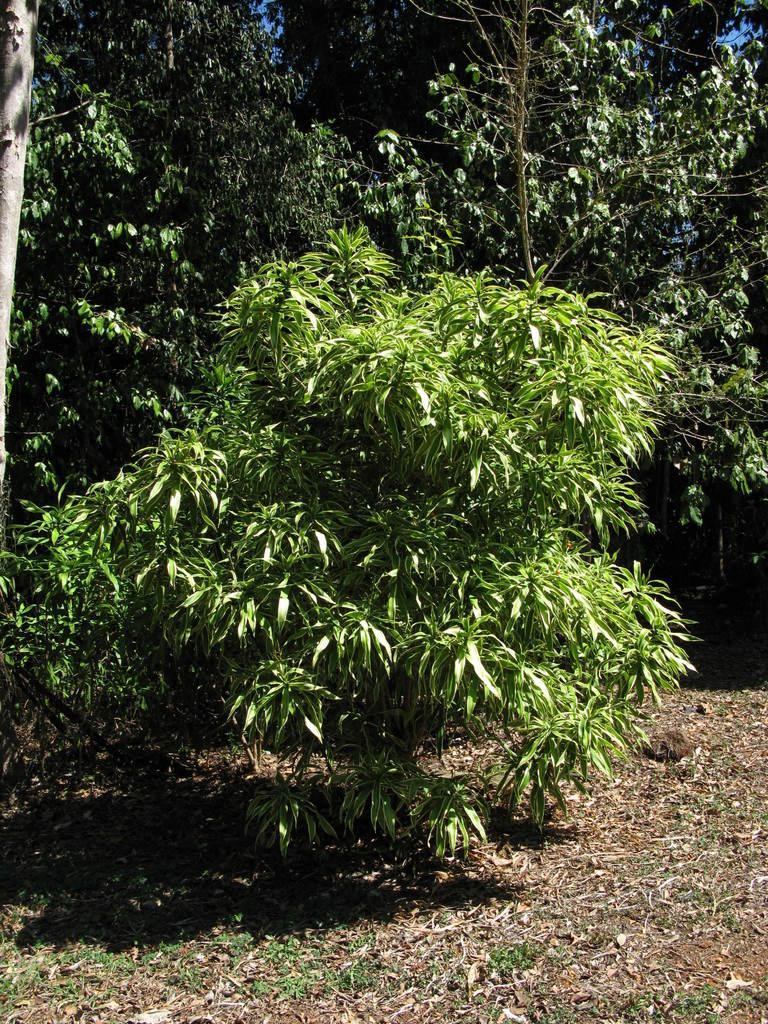Can you describe this image briefly? In this image, we can see trees and at the bottom, there is ground. 